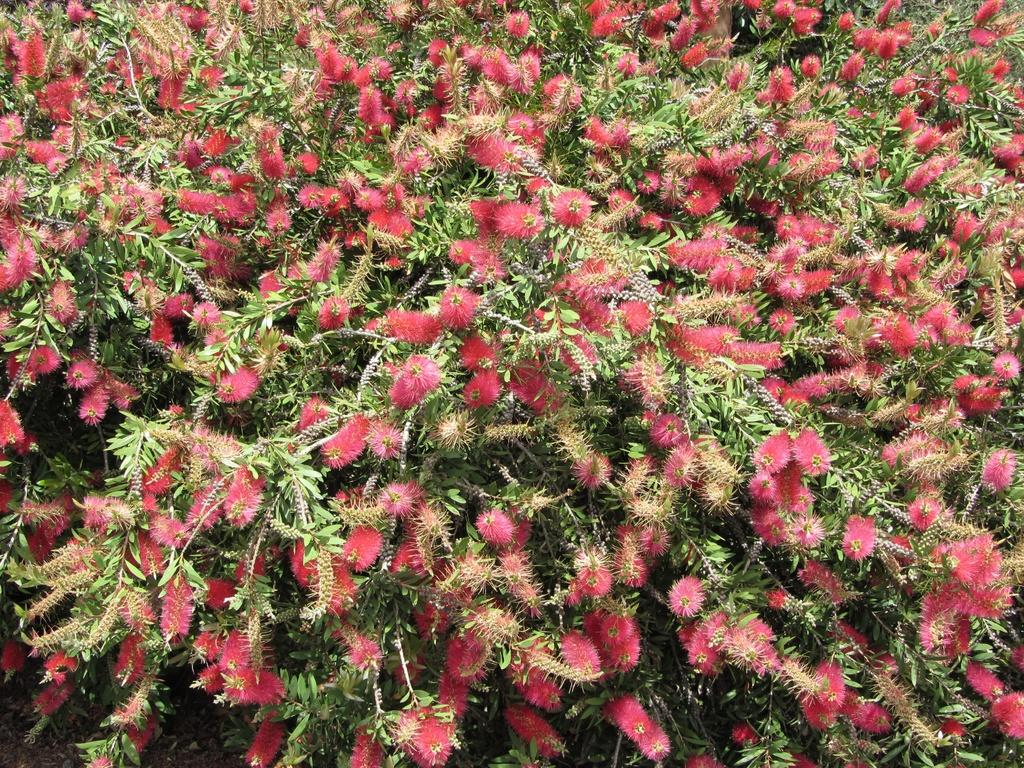What can be seen growing on the plants in the image? There are many flowers on the plants in the image. What else can be seen at the bottom of the plants? There are leaves visible at the bottom of the plants in the image. What type of shade is provided by the flowers in the image? There is no mention of shade in the image, as it focuses on the flowers and leaves on the plants. 